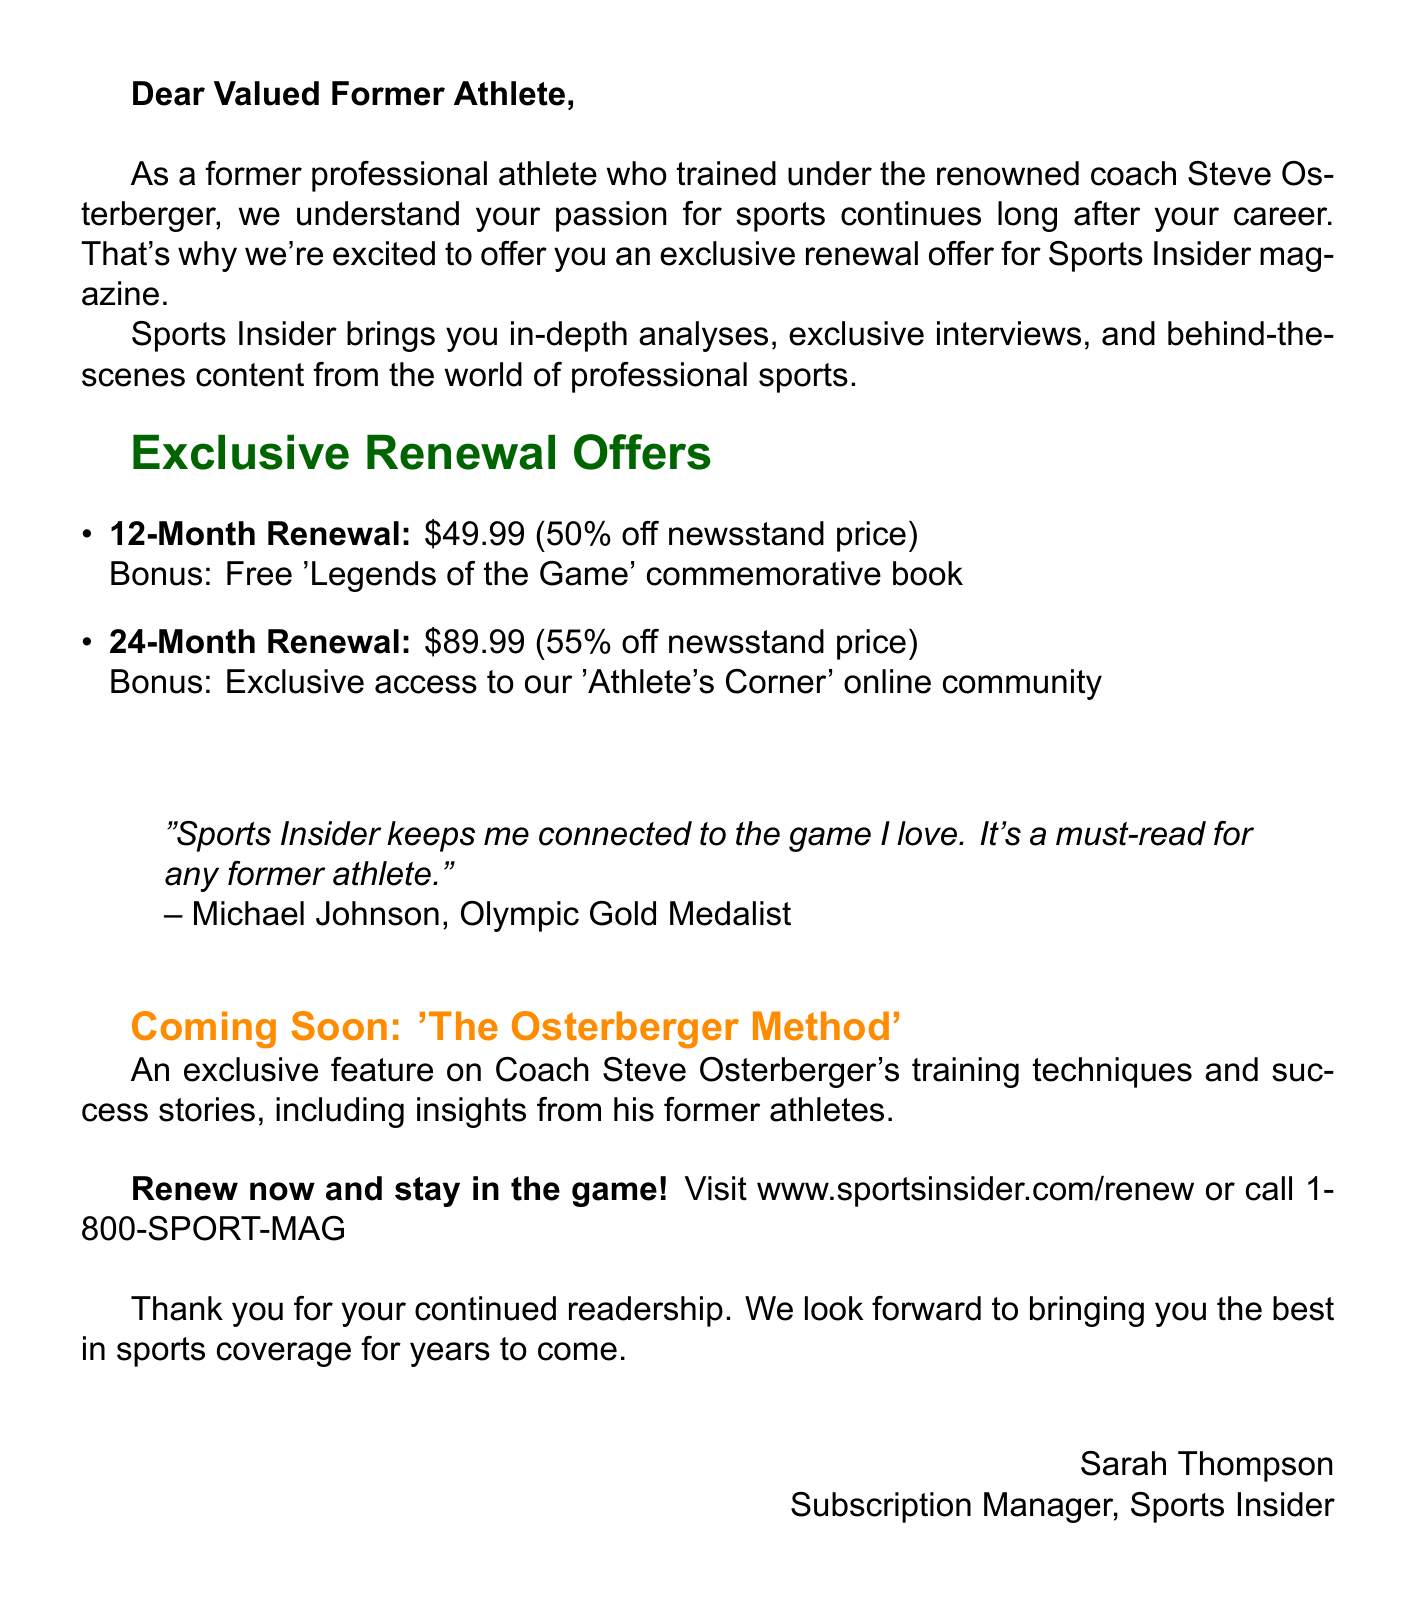What is the name of the magazine? The magazine is referred to by its name in the header of the document.
Answer: Sports Insider What is the tagline of Sports Insider? The tagline is listed right below the magazine name in the header.
Answer: The Ultimate Magazine for Professional Athletes and Sports Enthusiasts What is the price for the 12-month renewal? The price is stated under the special offers section for the 12-month renewal.
Answer: $49.99 What bonus comes with the 24-month renewal? The bonus for the 24-month renewal is mentioned in the same section.
Answer: Exclusive access to our 'Athlete's Corner' online community Who is quoted in the testimonial? The author of the testimonial is clearly mentioned after the quote in the document.
Answer: Michael Johnson What is the discount percentage for the 12-month renewal offer? This discount is also outlined in the special offers section of the document.
Answer: 50% off newsstand price What is the topic of the exclusive content coming soon? The topic is clearly stated in the exclusive content section of the document.
Answer: The Osterberger Method Who is the subscription manager for Sports Insider? The name is provided in the signature section at the end of the document.
Answer: Sarah Thompson What call to action is included in the document? The call to action is explicitly stated to encourage renewal.
Answer: Renew now and stay in the game! 